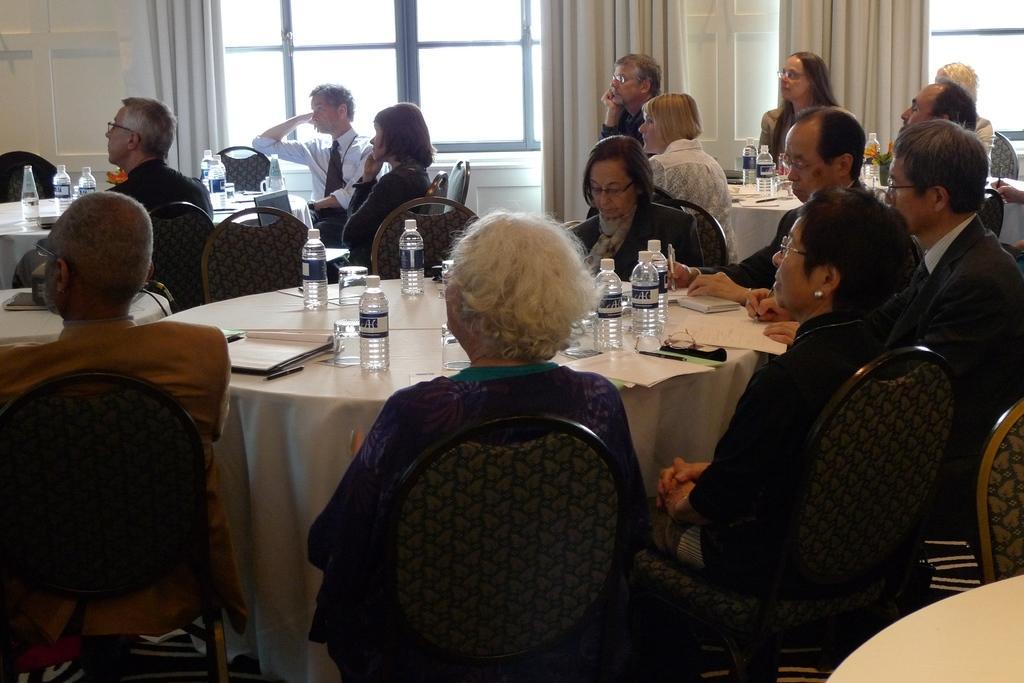Can you describe this image briefly? In this image we can see people sitting on the chairs around the table. We can see bottles and books on table. In the background we can see windows and curtains. 